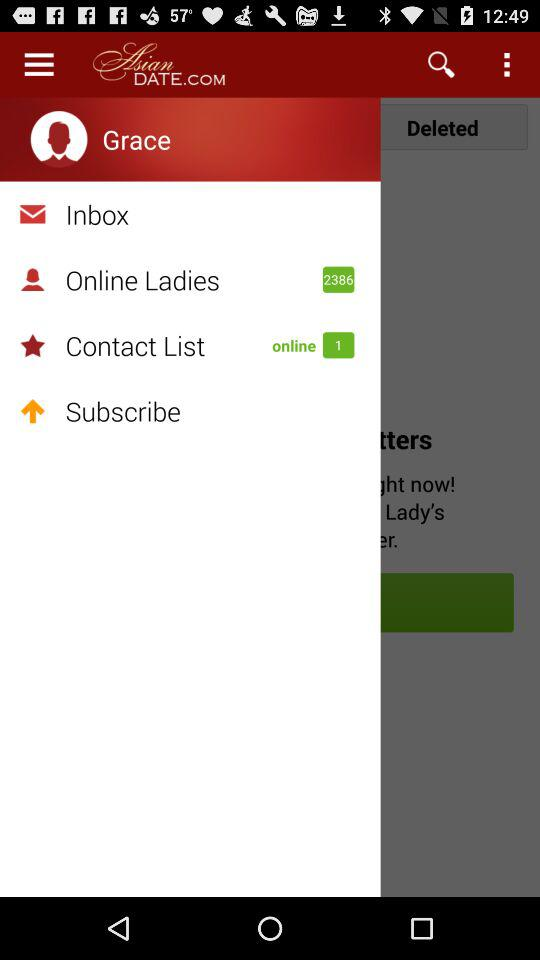What is the application name? The application name is "AsianDATE.COM". 